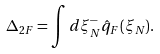<formula> <loc_0><loc_0><loc_500><loc_500>\Delta _ { 2 F } = \int d \xi ^ { - } _ { N } \hat { q } _ { F } ( \xi _ { N } ) .</formula> 